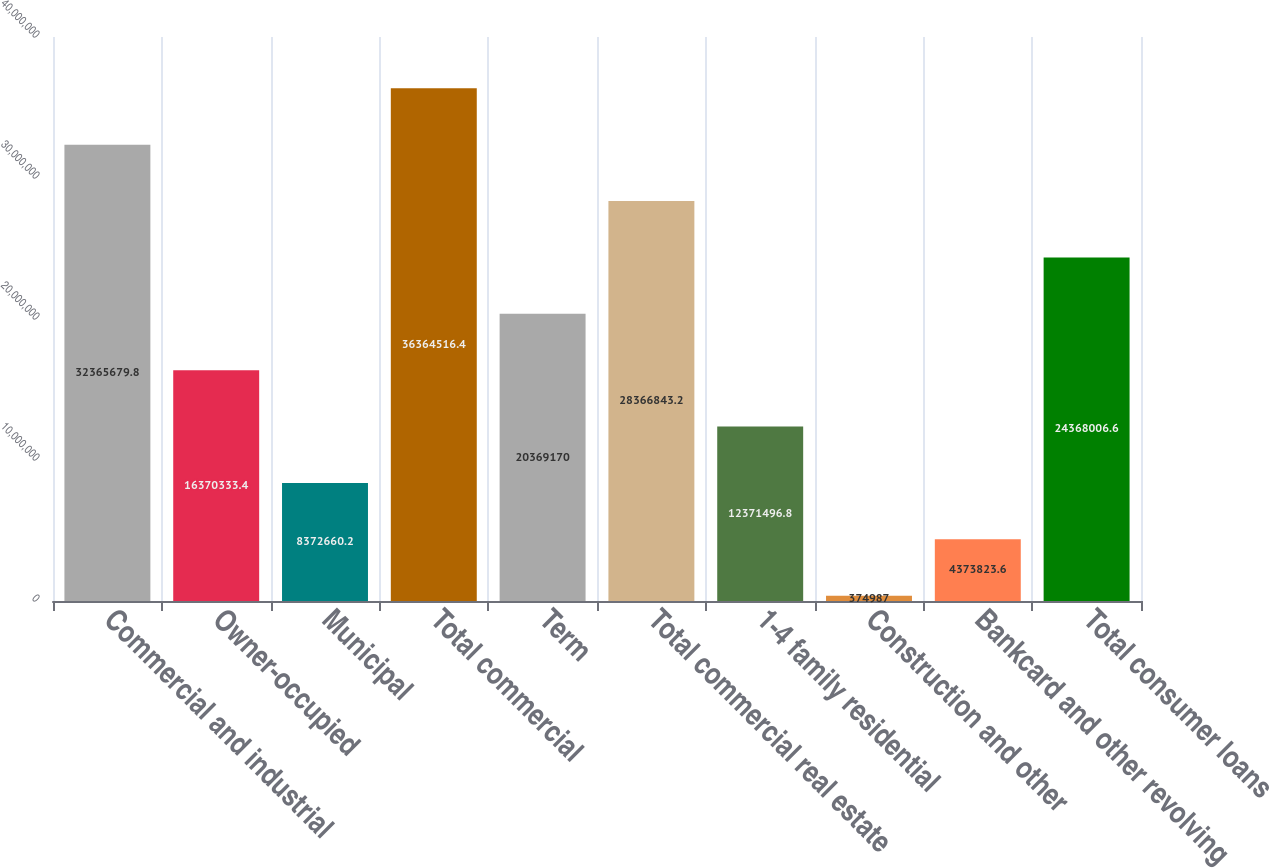Convert chart. <chart><loc_0><loc_0><loc_500><loc_500><bar_chart><fcel>Commercial and industrial<fcel>Owner-occupied<fcel>Municipal<fcel>Total commercial<fcel>Term<fcel>Total commercial real estate<fcel>1-4 family residential<fcel>Construction and other<fcel>Bankcard and other revolving<fcel>Total consumer loans<nl><fcel>3.23657e+07<fcel>1.63703e+07<fcel>8.37266e+06<fcel>3.63645e+07<fcel>2.03692e+07<fcel>2.83668e+07<fcel>1.23715e+07<fcel>374987<fcel>4.37382e+06<fcel>2.4368e+07<nl></chart> 